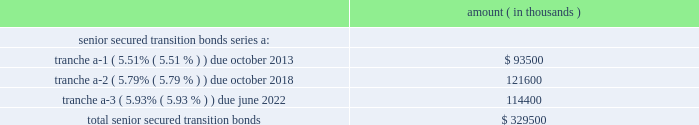Entergy corporation and subsidiaries notes to financial statements entergy new orleans securitization bonds - hurricane isaac in may 2015 the city council issued a financing order authorizing the issuance of securitization bonds to recover entergy new orleans 2019s hurricane isaac storm restoration costs of $ 31.8 million , including carrying costs , the costs of funding and replenishing the storm recovery reserve in the amount of $ 63.9 million , and approximately $ 3 million of up-front financing costs associated with the securitization .
In july 2015 , entergy new orleans storm recovery funding i , l.l.c. , a company wholly owned and consolidated by entergy new orleans , issued $ 98.7 million of storm cost recovery bonds .
The bonds have a coupon of 2.67% ( 2.67 % ) and an expected maturity date of june 2024 .
Although the principal amount is not due until the date given above , entergy new orleans storm recovery funding expects to make principal payments on the bonds over the next five years in the amounts of $ 11.4 million for 2016 , $ 10.6 million for 2017 , $ 11 million for 2018 , $ 11.2 million for 2019 , and $ 11.6 million for 2020 .
With the proceeds , entergy new orleans storm recovery funding purchased from entergy new orleans the storm recovery property , which is the right to recover from customers through a storm recovery charge amounts sufficient to service the securitization bonds .
The storm recovery property is reflected as a regulatory asset on the consolidated entergy new orleans balance sheet .
The creditors of entergy new orleans do not have recourse to the assets or revenues of entergy new orleans storm recovery funding , including the storm recovery property , and the creditors of entergy new orleans storm recovery funding do not have recourse to the assets or revenues of entergy new orleans .
Entergy new orleans has no payment obligations to entergy new orleans storm recovery funding except to remit storm recovery charge collections .
Entergy texas securitization bonds - hurricane rita in april 2007 the puct issued a financing order authorizing the issuance of securitization bonds to recover $ 353 million of entergy texas 2019s hurricane rita reconstruction costs and up to $ 6 million of transaction costs , offset by $ 32 million of related deferred income tax benefits .
In june 2007 , entergy gulf states reconstruction funding i , llc , a company that is now wholly-owned and consolidated by entergy texas , issued $ 329.5 million of senior secured transition bonds ( securitization bonds ) as follows : amount ( in thousands ) .
Although the principal amount of each tranche is not due until the dates given above , entergy gulf states reconstruction funding expects to make principal payments on the bonds over the next five years in the amounts of $ 26 million for 2016 , $ 27.6 million for 2017 , $ 29.2 million for 2018 , $ 30.9 million for 2019 , and $ 32.8 million for 2020 .
All of the scheduled principal payments for 2016 are for tranche a-2 , $ 23.6 million of the scheduled principal payments for 2017 are for tranche a-2 and $ 4 million of the scheduled principal payments for 2017 are for tranche a-3 .
All of the scheduled principal payments for 2018-2020 are for tranche a-3 .
With the proceeds , entergy gulf states reconstruction funding purchased from entergy texas the transition property , which is the right to recover from customers through a transition charge amounts sufficient to service the securitization bonds .
The transition property is reflected as a regulatory asset on the consolidated entergy texas balance sheet .
The creditors of entergy texas do not have recourse to the assets or revenues of entergy gulf states reconstruction funding , including the transition property , and the creditors of entergy gulf states reconstruction funding do not have recourse to the assets or revenues of entergy texas .
Entergy texas has no payment obligations to entergy gulf states reconstruction funding except to remit transition charge collections. .
What is the principal payment in 2017 as a percentage of the total senior secured transition bonds? 
Computations: ((27.6 * 1000) / 329500)
Answer: 0.08376. 